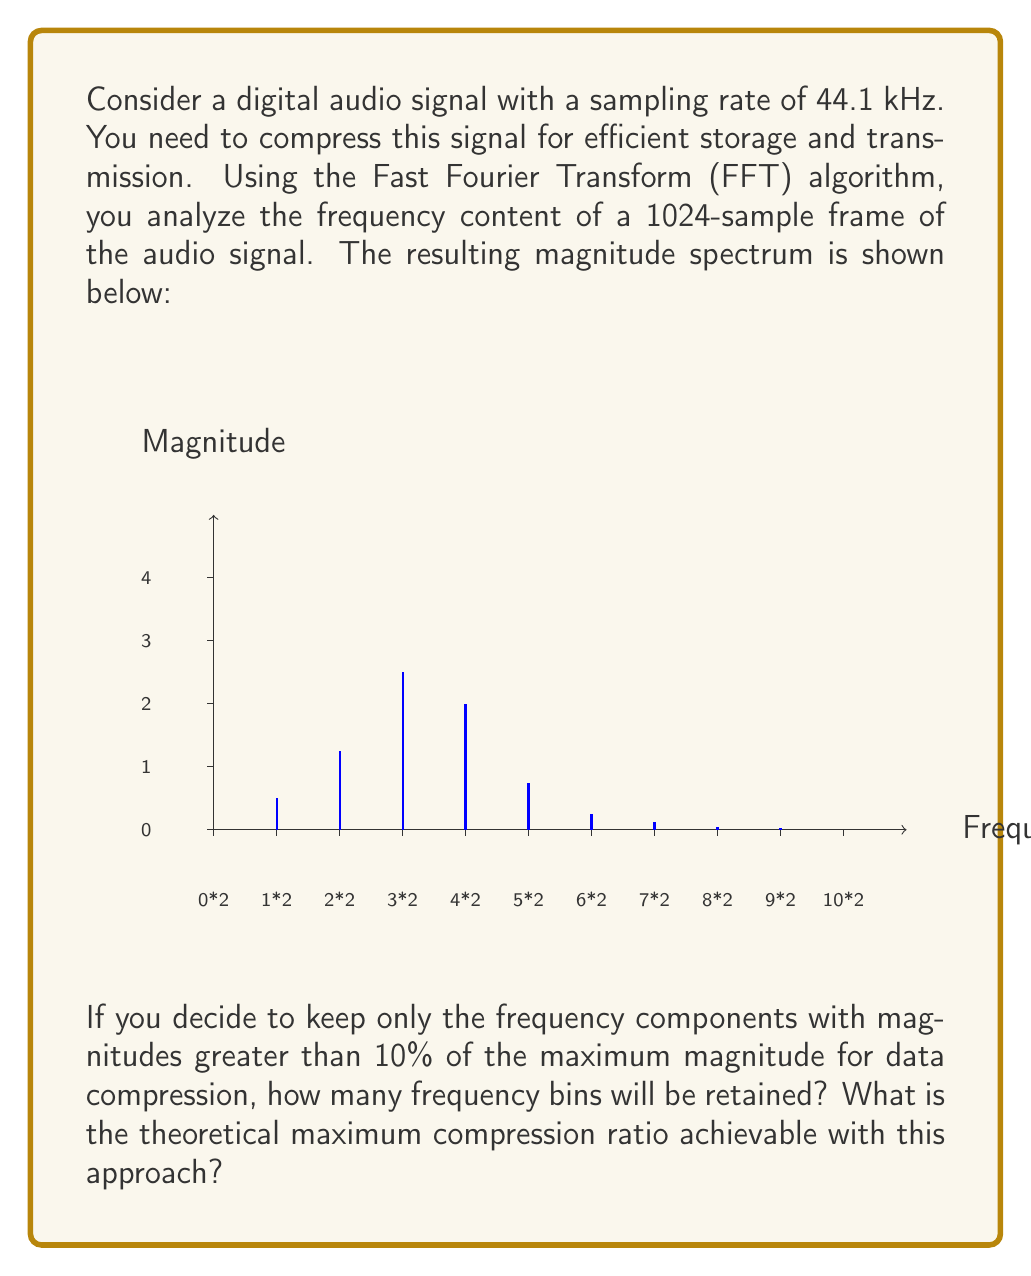Help me with this question. Let's approach this step-by-step:

1) First, we need to understand what the graph represents. The x-axis shows frequency bins from 0 to 22.05 kHz (half the sampling rate), divided into 10 equal parts. Each part represents 2.205 kHz.

2) The y-axis shows the magnitude of each frequency component.

3) To determine which frequency bins to keep, we need to find the maximum magnitude and calculate the threshold:

   Maximum magnitude = 1.0
   Threshold = 10% of maximum = 0.1

4) Counting the bins with magnitude greater than 0.1:
   
   Bin 1 (0-2.205 kHz): 0.2 > 0.1
   Bin 2 (2.205-4.41 kHz): 0.5 > 0.1
   Bin 3 (4.41-6.615 kHz): 1.0 > 0.1
   Bin 4 (6.615-8.82 kHz): 0.8 > 0.1
   Bin 5 (8.82-11.025 kHz): 0.3 > 0.1
   Bin 6 (11.025-13.23 kHz): 0.1 = 0.1 (we'll include this)

   All other bins are below the threshold.

5) Total bins retained: 6

6) To calculate the maximum compression ratio:
   
   Original data: 1024 samples (time domain)
   Compressed data: 6 complex numbers (frequency domain)

   Each complex number requires 2 float values (real and imaginary parts).
   Assuming 32-bit floats, the compressed data size is:
   
   6 * 2 * 32 = 384 bits

   The original data size (assuming 16-bit audio samples):
   
   1024 * 16 = 16,384 bits

7) The compression ratio is thus:

   $$\text{Compression Ratio} = \frac{\text{Original Size}}{\text{Compressed Size}} = \frac{16,384}{384} = 42.67$$

Therefore, the maximum theoretical compression ratio is approximately 42.67:1.
Answer: 6 bins retained; 42.67:1 compression ratio 